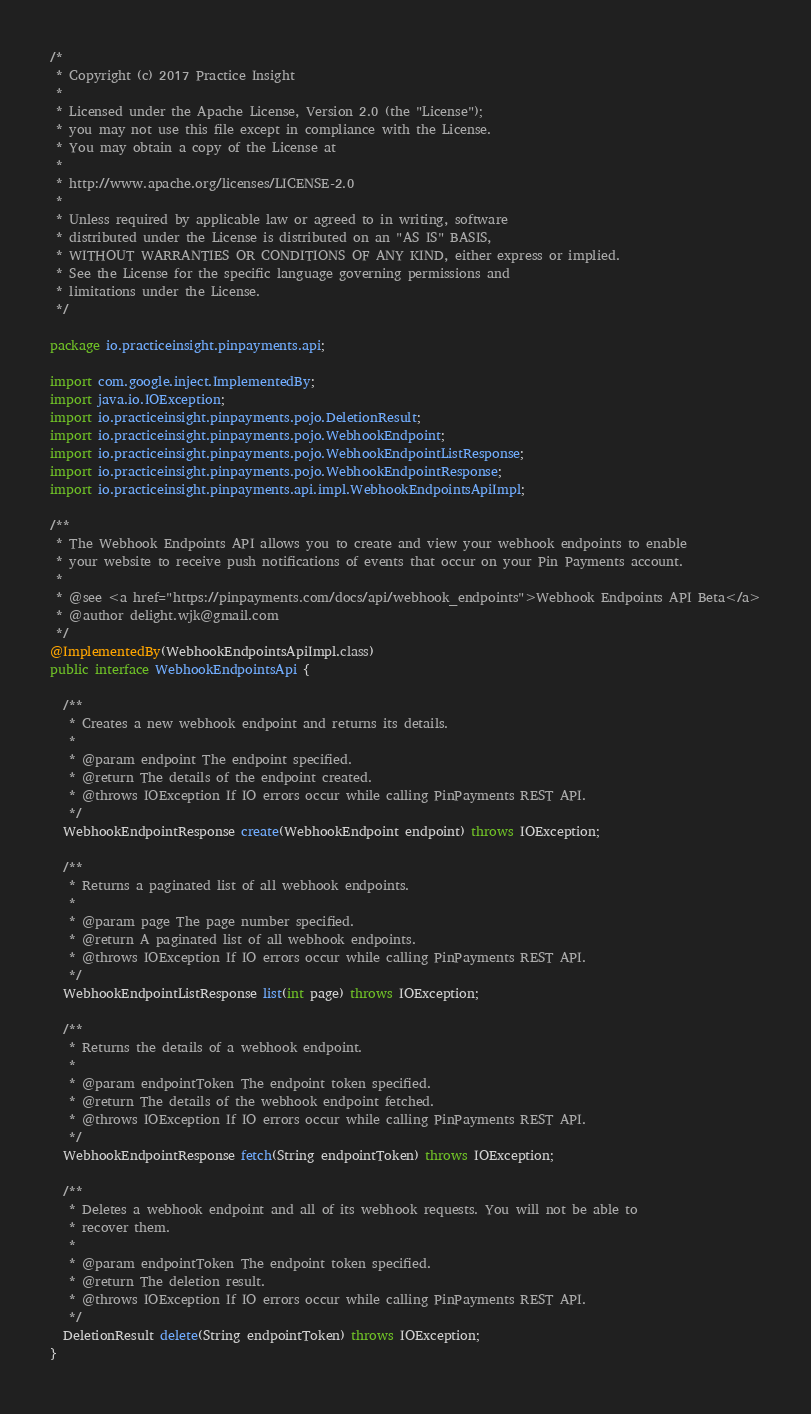Convert code to text. <code><loc_0><loc_0><loc_500><loc_500><_Java_>/*
 * Copyright (c) 2017 Practice Insight
 *
 * Licensed under the Apache License, Version 2.0 (the "License");
 * you may not use this file except in compliance with the License.
 * You may obtain a copy of the License at
 *
 * http://www.apache.org/licenses/LICENSE-2.0
 *
 * Unless required by applicable law or agreed to in writing, software
 * distributed under the License is distributed on an "AS IS" BASIS,
 * WITHOUT WARRANTIES OR CONDITIONS OF ANY KIND, either express or implied.
 * See the License for the specific language governing permissions and
 * limitations under the License.
 */

package io.practiceinsight.pinpayments.api;

import com.google.inject.ImplementedBy;
import java.io.IOException;
import io.practiceinsight.pinpayments.pojo.DeletionResult;
import io.practiceinsight.pinpayments.pojo.WebhookEndpoint;
import io.practiceinsight.pinpayments.pojo.WebhookEndpointListResponse;
import io.practiceinsight.pinpayments.pojo.WebhookEndpointResponse;
import io.practiceinsight.pinpayments.api.impl.WebhookEndpointsApiImpl;

/**
 * The Webhook Endpoints API allows you to create and view your webhook endpoints to enable
 * your website to receive push notifications of events that occur on your Pin Payments account.
 *
 * @see <a href="https://pinpayments.com/docs/api/webhook_endpoints">Webhook Endpoints API Beta</a>
 * @author delight.wjk@gmail.com
 */
@ImplementedBy(WebhookEndpointsApiImpl.class)
public interface WebhookEndpointsApi {

  /**
   * Creates a new webhook endpoint and returns its details.
   *
   * @param endpoint The endpoint specified.
   * @return The details of the endpoint created.
   * @throws IOException If IO errors occur while calling PinPayments REST API.
   */
  WebhookEndpointResponse create(WebhookEndpoint endpoint) throws IOException;

  /**
   * Returns a paginated list of all webhook endpoints.
   *
   * @param page The page number specified.
   * @return A paginated list of all webhook endpoints.
   * @throws IOException If IO errors occur while calling PinPayments REST API.
   */
  WebhookEndpointListResponse list(int page) throws IOException;

  /**
   * Returns the details of a webhook endpoint.
   *
   * @param endpointToken The endpoint token specified.
   * @return The details of the webhook endpoint fetched.
   * @throws IOException If IO errors occur while calling PinPayments REST API.
   */
  WebhookEndpointResponse fetch(String endpointToken) throws IOException;

  /**
   * Deletes a webhook endpoint and all of its webhook requests. You will not be able to
   * recover them.
   *
   * @param endpointToken The endpoint token specified.
   * @return The deletion result.
   * @throws IOException If IO errors occur while calling PinPayments REST API.
   */
  DeletionResult delete(String endpointToken) throws IOException;
}
</code> 